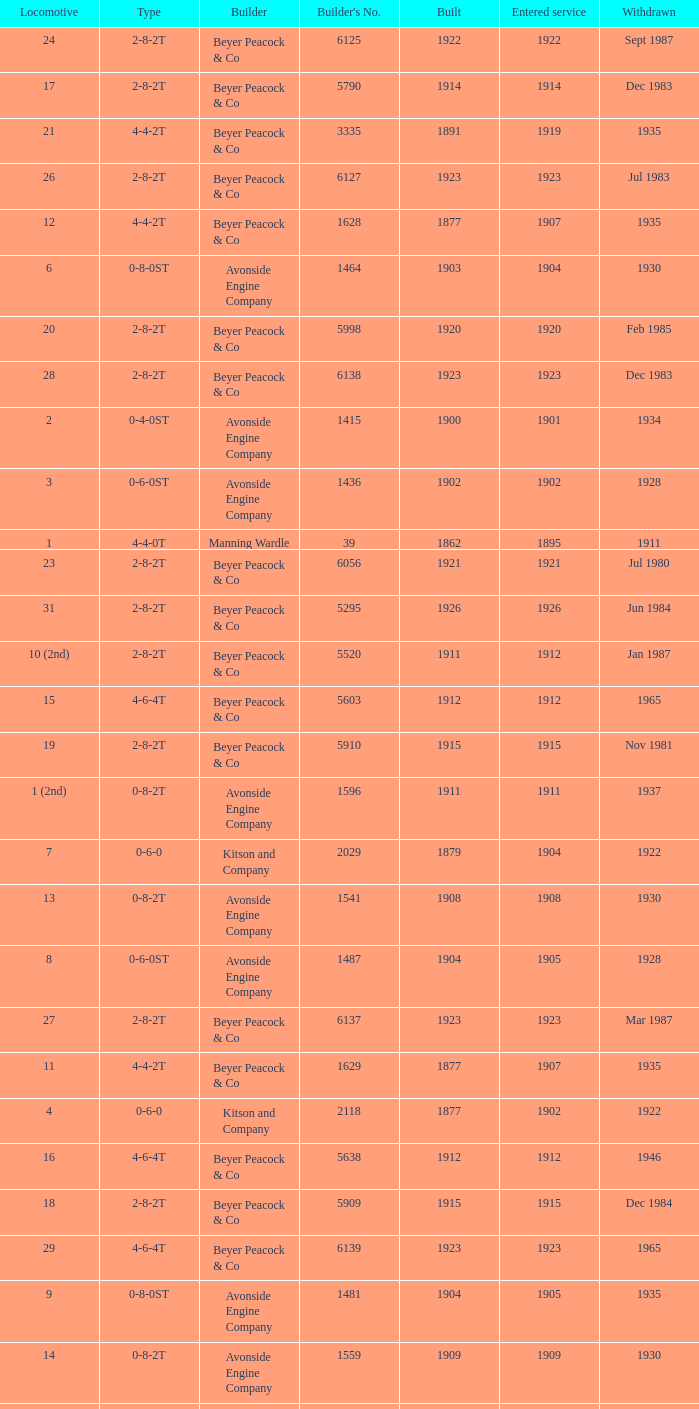How many years entered service when there were 13 locomotives? 1.0. Could you parse the entire table as a dict? {'header': ['Locomotive', 'Type', 'Builder', "Builder's No.", 'Built', 'Entered service', 'Withdrawn'], 'rows': [['24', '2-8-2T', 'Beyer Peacock & Co', '6125', '1922', '1922', 'Sept 1987'], ['17', '2-8-2T', 'Beyer Peacock & Co', '5790', '1914', '1914', 'Dec 1983'], ['21', '4-4-2T', 'Beyer Peacock & Co', '3335', '1891', '1919', '1935'], ['26', '2-8-2T', 'Beyer Peacock & Co', '6127', '1923', '1923', 'Jul 1983'], ['12', '4-4-2T', 'Beyer Peacock & Co', '1628', '1877', '1907', '1935'], ['6', '0-8-0ST', 'Avonside Engine Company', '1464', '1903', '1904', '1930'], ['20', '2-8-2T', 'Beyer Peacock & Co', '5998', '1920', '1920', 'Feb 1985'], ['28', '2-8-2T', 'Beyer Peacock & Co', '6138', '1923', '1923', 'Dec 1983'], ['2', '0-4-0ST', 'Avonside Engine Company', '1415', '1900', '1901', '1934'], ['3', '0-6-0ST', 'Avonside Engine Company', '1436', '1902', '1902', '1928'], ['1', '4-4-0T', 'Manning Wardle', '39', '1862', '1895', '1911'], ['23', '2-8-2T', 'Beyer Peacock & Co', '6056', '1921', '1921', 'Jul 1980'], ['31', '2-8-2T', 'Beyer Peacock & Co', '5295', '1926', '1926', 'Jun 1984'], ['10 (2nd)', '2-8-2T', 'Beyer Peacock & Co', '5520', '1911', '1912', 'Jan 1987'], ['15', '4-6-4T', 'Beyer Peacock & Co', '5603', '1912', '1912', '1965'], ['19', '2-8-2T', 'Beyer Peacock & Co', '5910', '1915', '1915', 'Nov 1981'], ['1 (2nd)', '0-8-2T', 'Avonside Engine Company', '1596', '1911', '1911', '1937'], ['7', '0-6-0', 'Kitson and Company', '2029', '1879', '1904', '1922'], ['13', '0-8-2T', 'Avonside Engine Company', '1541', '1908', '1908', '1930'], ['8', '0-6-0ST', 'Avonside Engine Company', '1487', '1904', '1905', '1928'], ['27', '2-8-2T', 'Beyer Peacock & Co', '6137', '1923', '1923', 'Mar 1987'], ['11', '4-4-2T', 'Beyer Peacock & Co', '1629', '1877', '1907', '1935'], ['4', '0-6-0', 'Kitson and Company', '2118', '1877', '1902', '1922'], ['16', '4-6-4T', 'Beyer Peacock & Co', '5638', '1912', '1912', '1946'], ['18', '2-8-2T', 'Beyer Peacock & Co', '5909', '1915', '1915', 'Dec 1984'], ['29', '4-6-4T', 'Beyer Peacock & Co', '6139', '1923', '1923', '1965'], ['9', '0-8-0ST', 'Avonside Engine Company', '1481', '1904', '1905', '1935'], ['14', '0-8-2T', 'Avonside Engine Company', '1559', '1909', '1909', '1930'], ['10', '0-6-0', 'Vale & Lacy, Sydney', '10', '1873', '1906', '1911'], ['5', '0-6-0', 'Kitson and Company', '2299', '1879', '1903', '1918'], ['22', '2-8-2T', 'Beyer Peacock & Co', '6055', '1921', '1921', 'Sept 1987'], ['30', '2-8-2T', 'Beyer Peacock & Co', '6294', '1926', '1926', 'Sept 1987'], ['25', '2-8-2T', 'Beyer Peacock & Co', '6126', '1923', '1923', 'Sept 1987']]} 